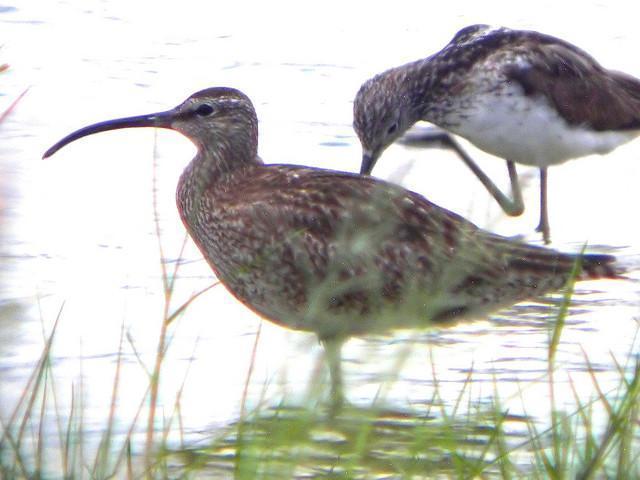How many birds can be seen?
Give a very brief answer. 2. How many people have on a hat?
Give a very brief answer. 0. 